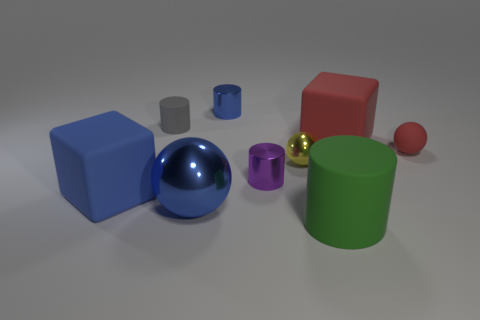Subtract all purple cylinders. How many cylinders are left? 3 Subtract all purple cylinders. How many cylinders are left? 3 Add 1 large red rubber blocks. How many objects exist? 10 Subtract all brown cylinders. Subtract all cyan balls. How many cylinders are left? 4 Subtract all cylinders. How many objects are left? 5 Add 9 green rubber cylinders. How many green rubber cylinders exist? 10 Subtract 0 purple spheres. How many objects are left? 9 Subtract all large green rubber balls. Subtract all rubber cylinders. How many objects are left? 7 Add 5 small blue objects. How many small blue objects are left? 6 